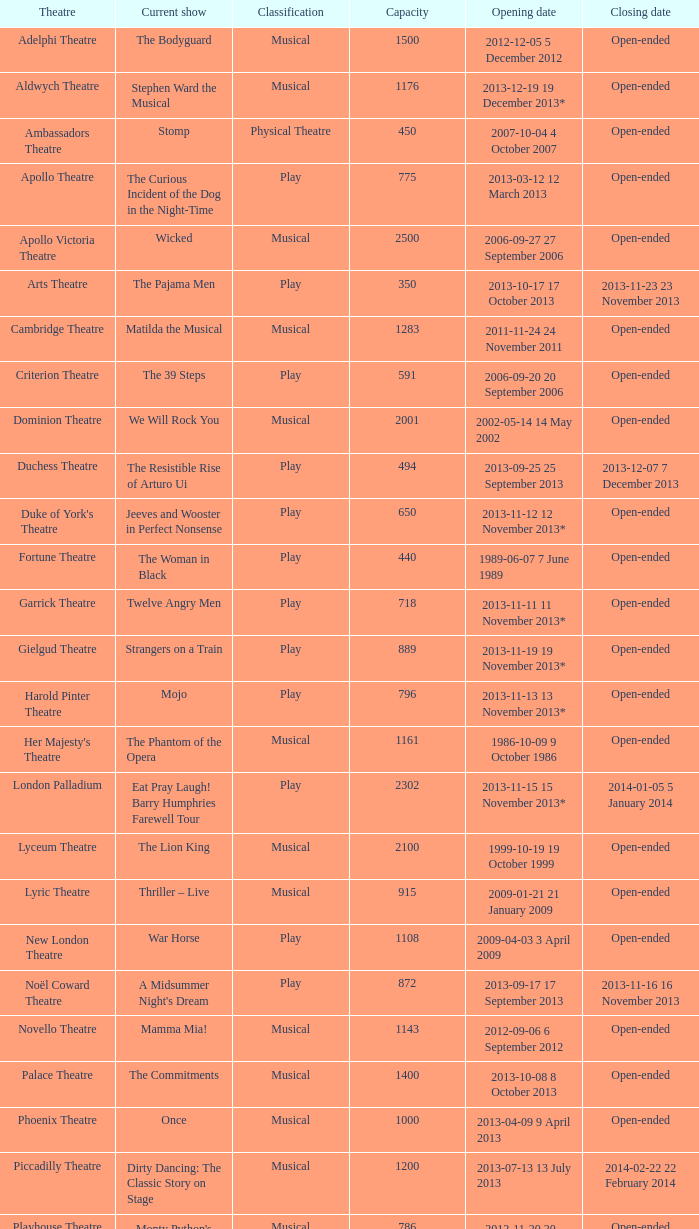When is the inauguration date of the musical at the adelphi theatre? 2012-12-05 5 December 2012. 